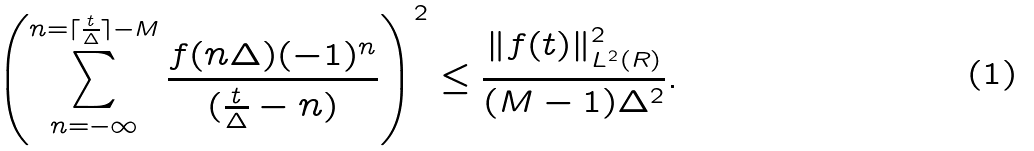<formula> <loc_0><loc_0><loc_500><loc_500>\left ( \sum _ { n = - \infty } ^ { n = \lceil \frac { t } { \Delta } \rceil - M } \frac { f ( n \Delta ) ( - 1 ) ^ { n } } { ( \frac { t } { \Delta } - n ) } \right ) ^ { 2 } \leq \frac { \| f ( t ) \| _ { L ^ { 2 } ( R ) } ^ { 2 } } { ( M - 1 ) { \Delta } ^ { 2 } } .</formula> 